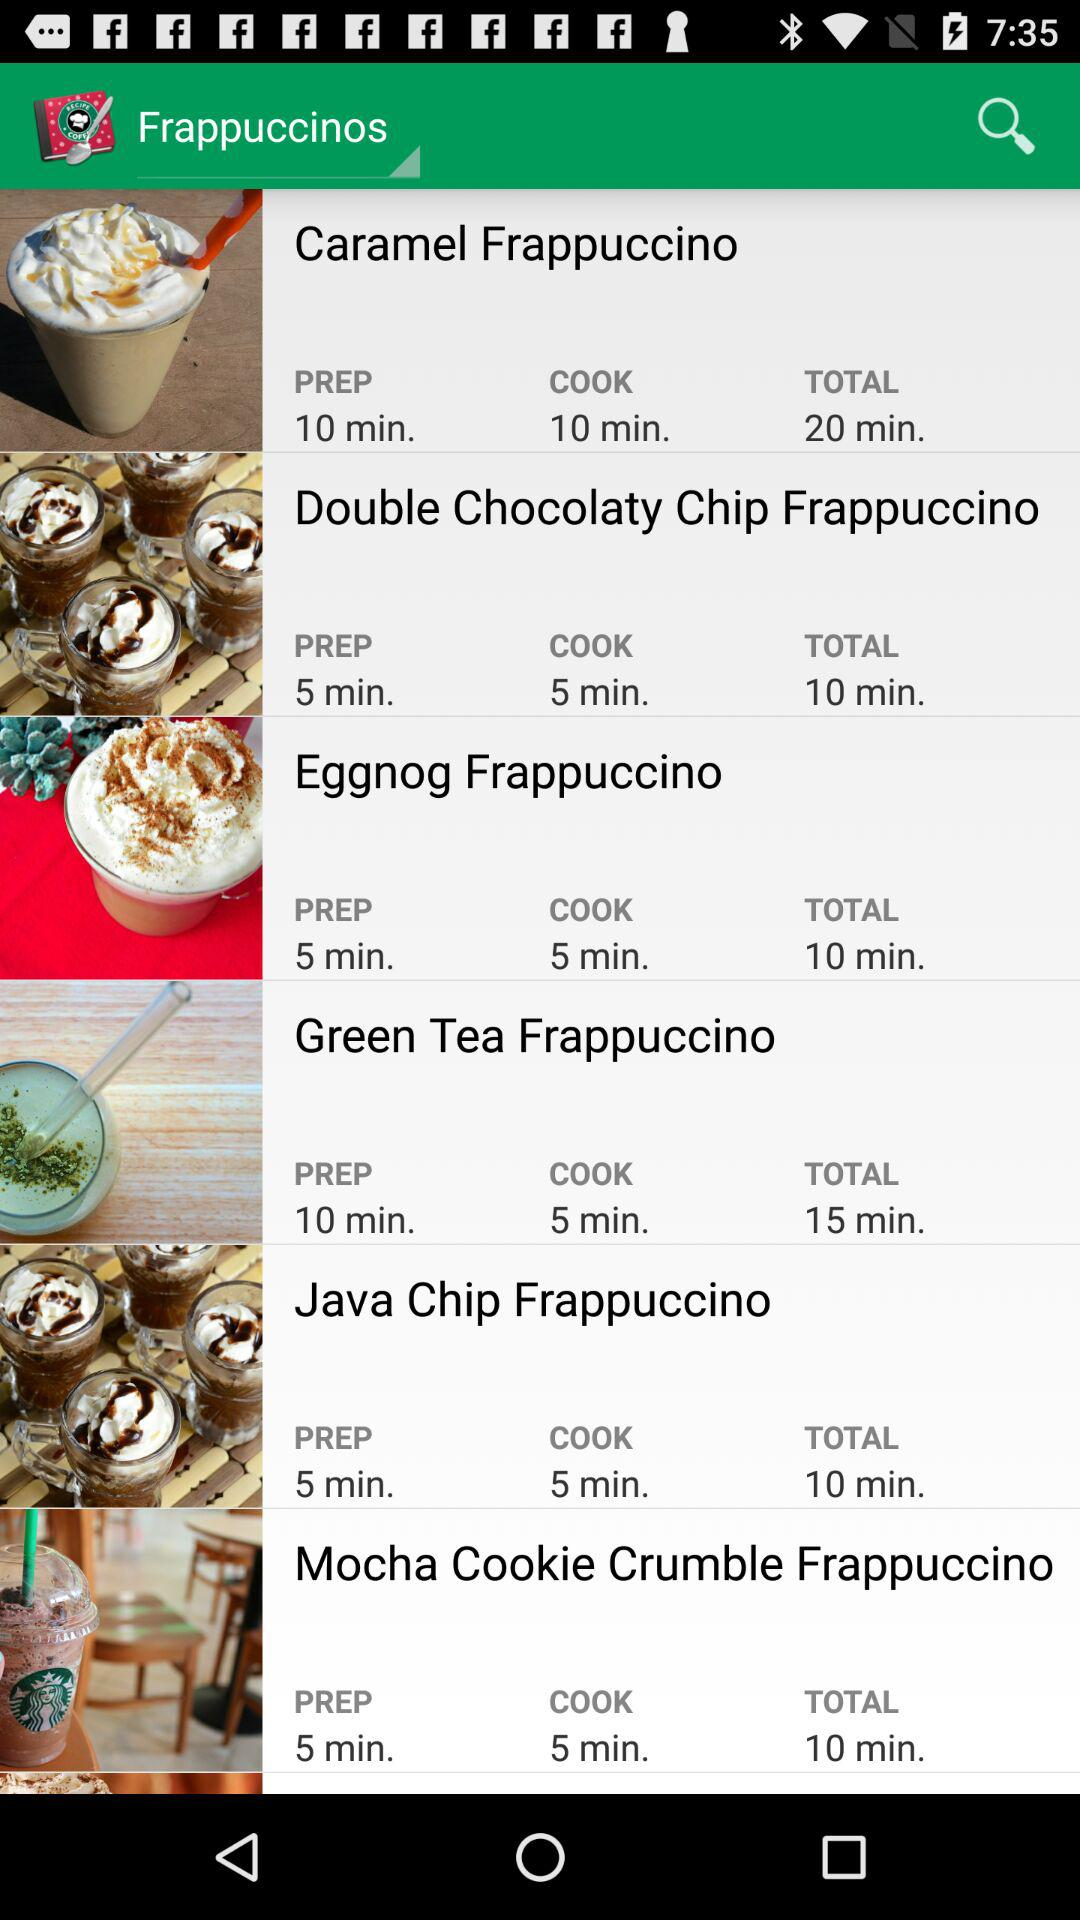How much eggnog is required to make one serving of the eggnog frappuccino?
When the provided information is insufficient, respond with <no answer>. <no answer> 